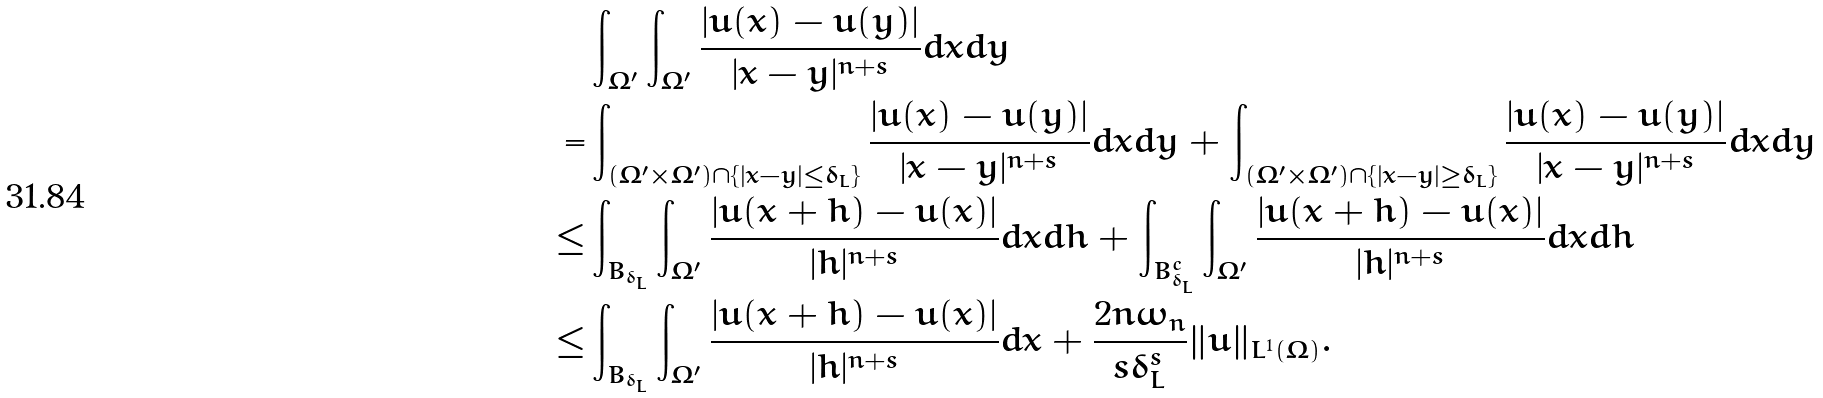<formula> <loc_0><loc_0><loc_500><loc_500>& \int _ { \Omega ^ { \prime } } \int _ { \Omega ^ { \prime } } \frac { | u ( x ) - u ( y ) | } { | x - y | ^ { n + s } } d x d y \\ = & \int _ { ( \Omega ^ { \prime } \times \Omega ^ { \prime } ) \cap \{ | x - y | \leq \delta _ { L } \} } \frac { | u ( x ) - u ( y ) | } { | x - y | ^ { n + s } } d x d y + \int _ { ( \Omega ^ { \prime } \times \Omega ^ { \prime } ) \cap \{ | x - y | \geq \delta _ { L } \} } \frac { | u ( x ) - u ( y ) | } { | x - y | ^ { n + s } } d x d y \\ \leq & \int _ { B _ { \delta _ { L } } } \int _ { \Omega ^ { \prime } } \frac { | u ( x + h ) - u ( x ) | } { | h | ^ { n + s } } d x d h + \int _ { B _ { \delta _ { L } } ^ { c } } \int _ { \Omega ^ { \prime } } \frac { | u ( x + h ) - u ( x ) | } { | h | ^ { n + s } } d x d h \\ \leq & \int _ { B _ { \delta _ { L } } } \int _ { \Omega ^ { \prime } } \frac { | u ( x + h ) - u ( x ) | } { | h | ^ { n + s } } d x + \frac { 2 n \omega _ { n } } { s \delta _ { L } ^ { s } } \| u \| _ { L ^ { 1 } ( \Omega ) } .</formula> 